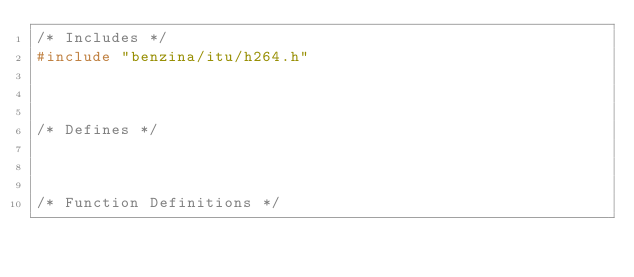Convert code to text. <code><loc_0><loc_0><loc_500><loc_500><_C_>/* Includes */
#include "benzina/itu/h264.h"



/* Defines */



/* Function Definitions */

</code> 